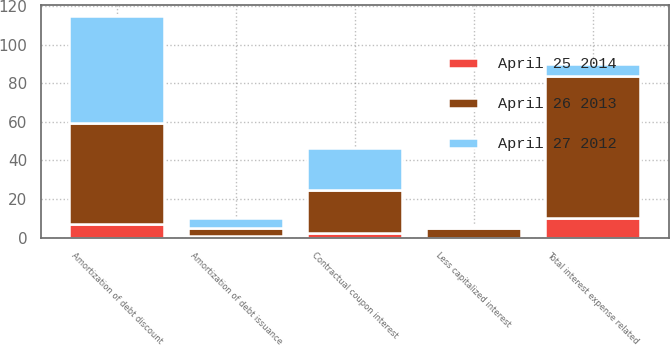Convert chart. <chart><loc_0><loc_0><loc_500><loc_500><stacked_bar_chart><ecel><fcel>Contractual coupon interest<fcel>Amortization of debt discount<fcel>Amortization of debt issuance<fcel>Less capitalized interest<fcel>Total interest expense related<nl><fcel>April 25 2014<fcel>2.5<fcel>7.1<fcel>0.6<fcel>0<fcel>10.2<nl><fcel>April 27 2012<fcel>22<fcel>55.5<fcel>4.8<fcel>1.1<fcel>6.05<nl><fcel>April 26 2013<fcel>22<fcel>52<fcel>4.5<fcel>5<fcel>73.5<nl></chart> 